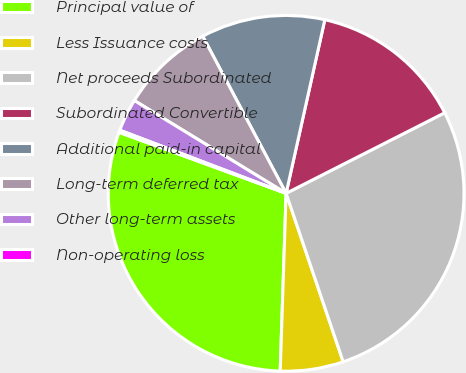Convert chart. <chart><loc_0><loc_0><loc_500><loc_500><pie_chart><fcel>Principal value of<fcel>Less Issuance costs<fcel>Net proceeds Subordinated<fcel>Subordinated Convertible<fcel>Additional paid-in capital<fcel>Long-term deferred tax<fcel>Other long-term assets<fcel>Non-operating loss<nl><fcel>30.05%<fcel>5.73%<fcel>27.28%<fcel>14.03%<fcel>11.26%<fcel>8.5%<fcel>2.96%<fcel>0.2%<nl></chart> 